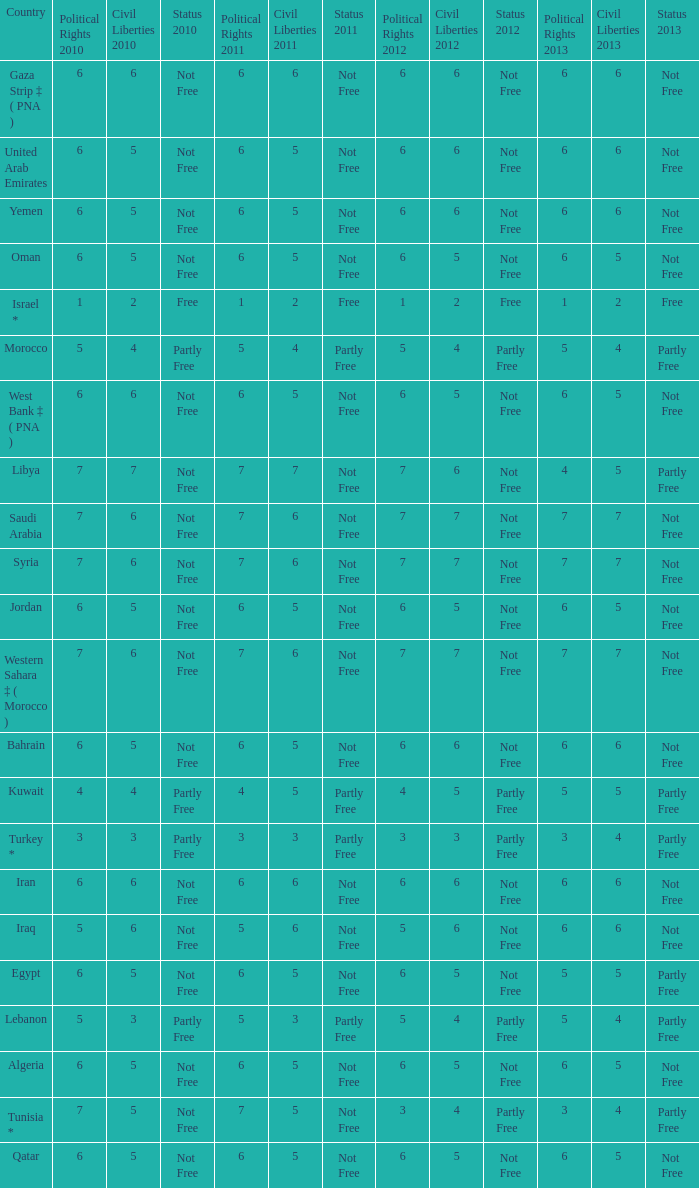What is the average 2012 civil liberties value associated with a 2011 status of not free, political rights 2012 over 6, and political rights 2011 over 7? None. 